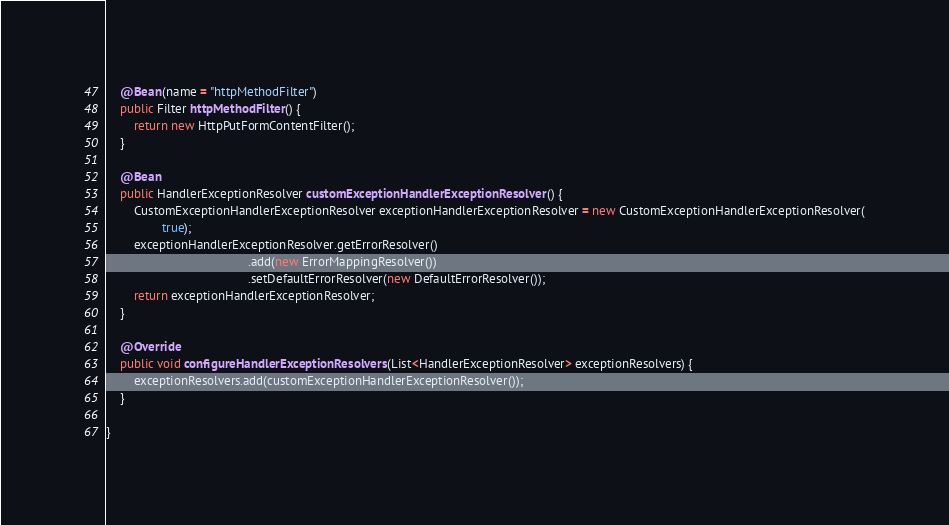Convert code to text. <code><loc_0><loc_0><loc_500><loc_500><_Java_>    @Bean(name = "httpMethodFilter")
    public Filter httpMethodFilter() {
        return new HttpPutFormContentFilter();
    }

    @Bean
    public HandlerExceptionResolver customExceptionHandlerExceptionResolver() {
        CustomExceptionHandlerExceptionResolver exceptionHandlerExceptionResolver = new CustomExceptionHandlerExceptionResolver(
                true);
        exceptionHandlerExceptionResolver.getErrorResolver()
                                         .add(new ErrorMappingResolver())
                                         .setDefaultErrorResolver(new DefaultErrorResolver());
        return exceptionHandlerExceptionResolver;
    }

    @Override
    public void configureHandlerExceptionResolvers(List<HandlerExceptionResolver> exceptionResolvers) {
        exceptionResolvers.add(customExceptionHandlerExceptionResolver());
    }

}
</code> 